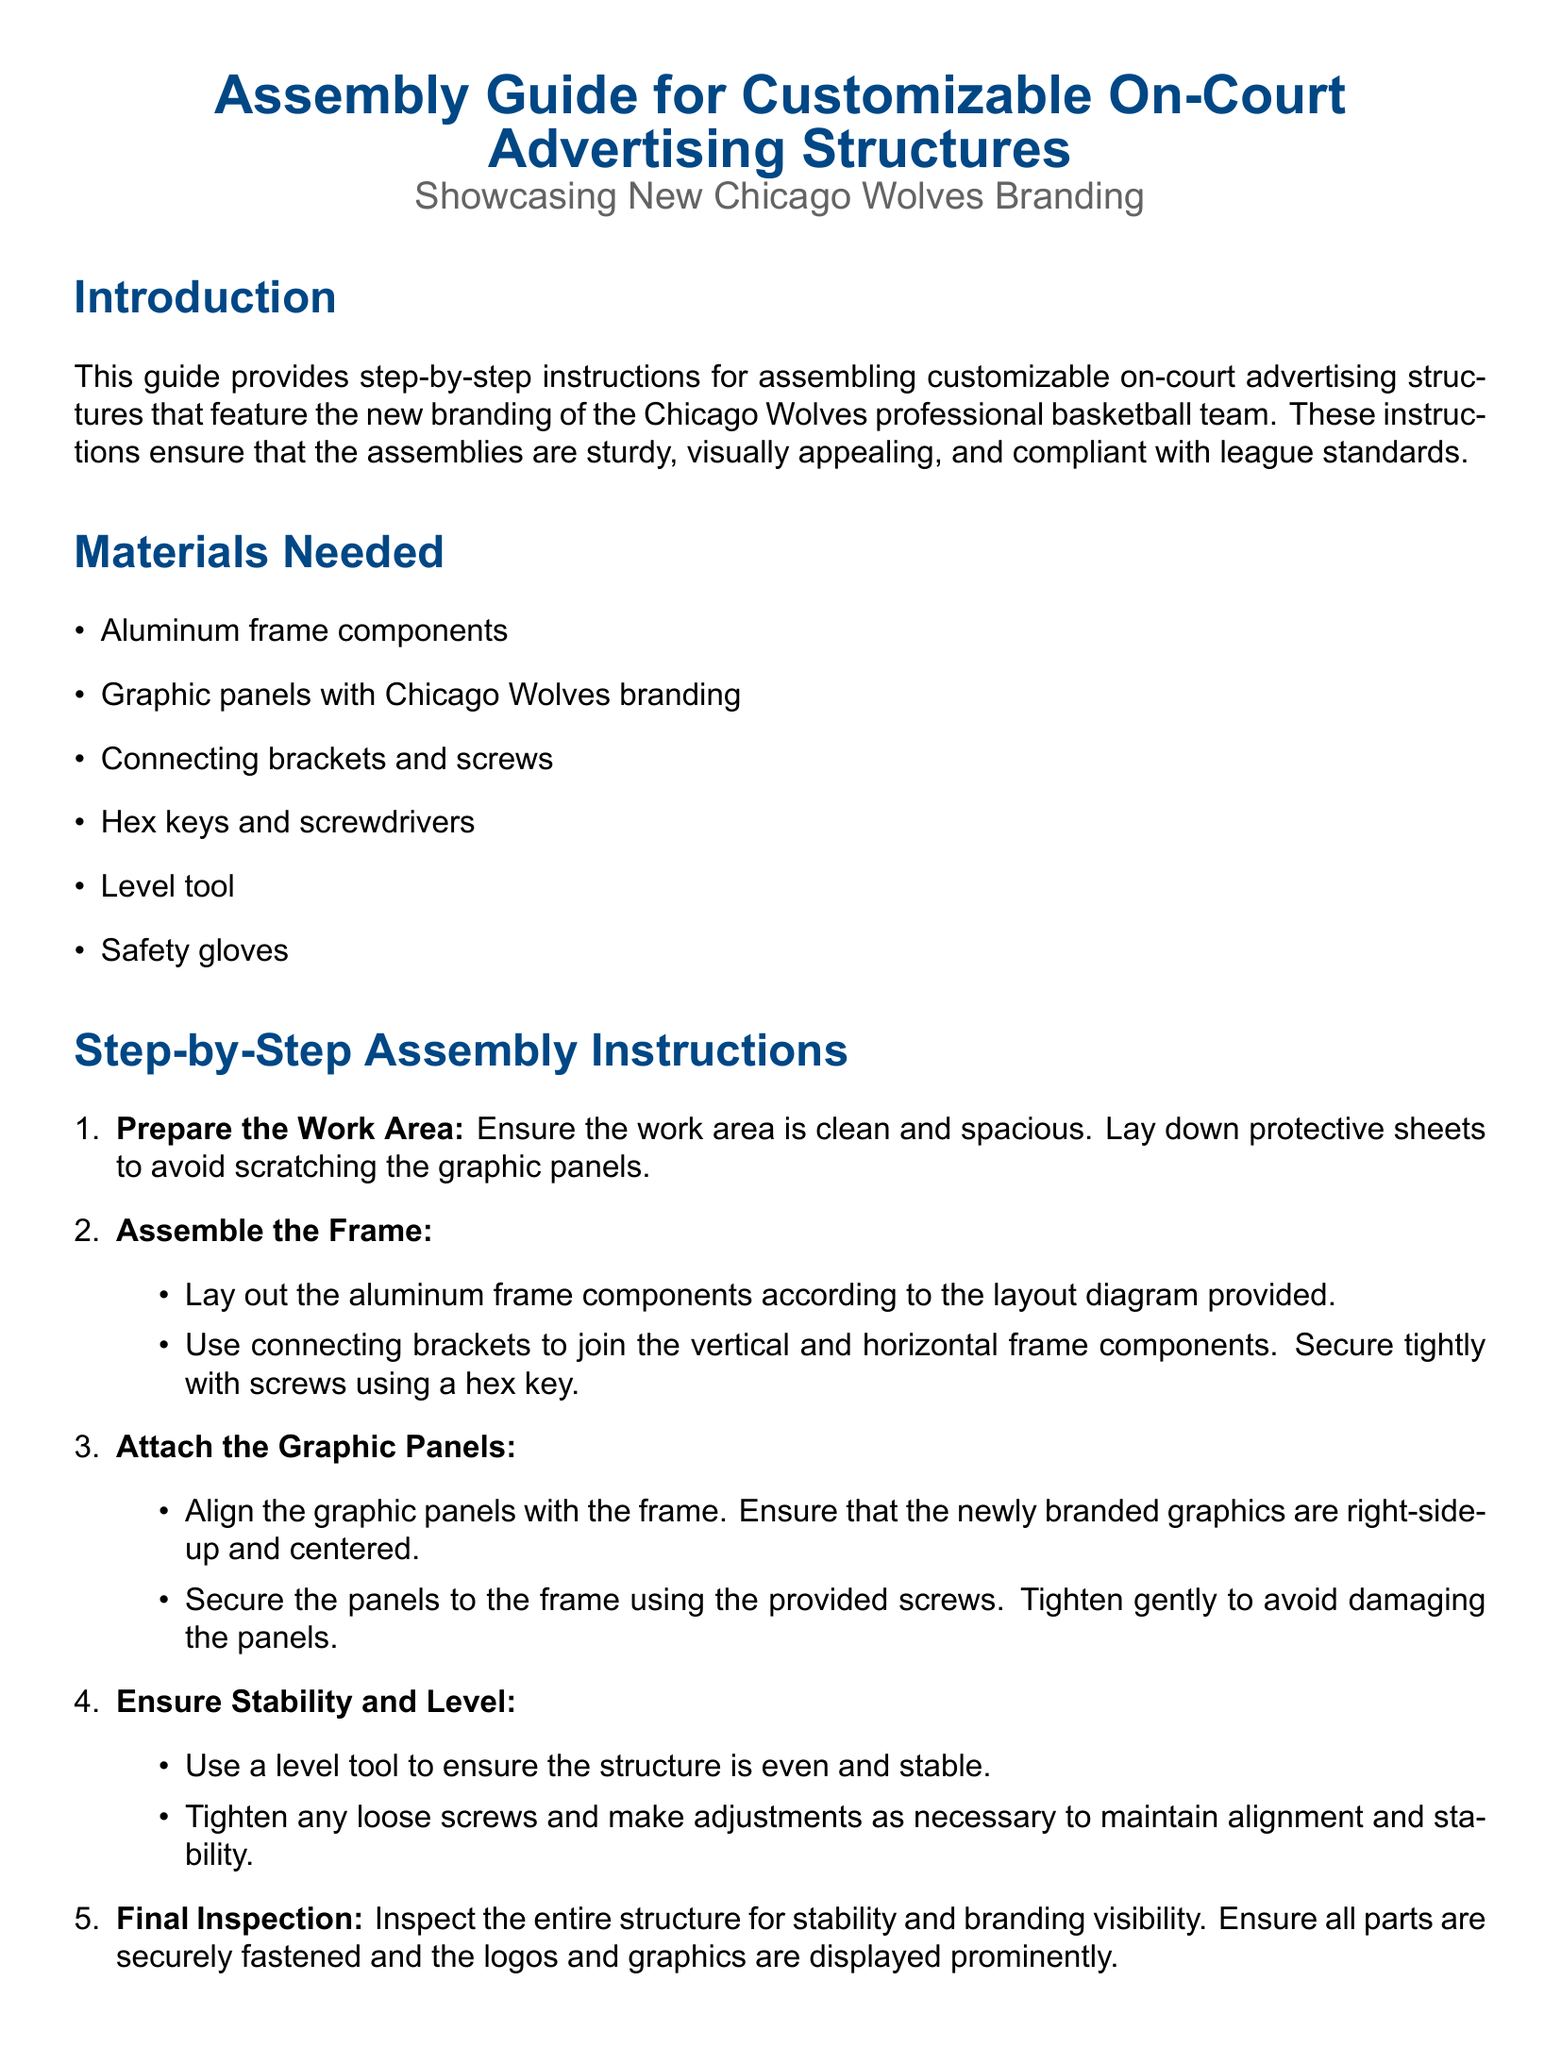What is the title of the document? The title is specified at the top of the document and gives insight into its content regarding assembly instructions.
Answer: Assembly Guide for Customizable On-Court Advertising Structures How many materials are needed for assembly? The materials needed are listed in a bulleted list within the document under "Materials Needed."
Answer: 6 What is the first step in the assembly instructions? The steps for assembly are presented in an enumerated list, with the first item describing the initial preparation needed.
Answer: Prepare the Work Area What color is the header text? The color for header text is defined in the document to help it stand out, specifically noted in the key sections.
Answer: Wolfblue What should you use to secure the graphic panels? The document specifies the tools and fasteners needed for securing components during assembly.
Answer: Provided screws What is the safety tip regarding hand protection? Information about safety measures is included in a list to ensure the safety of individuals assembling the structure.
Answer: Wear safety gloves Which tool is recommended for ensuring the structure is even? The instructions mention a specific tool needed to check the level of the assembled structure.
Answer: Level tool How can you contact the Chicago Wolves branding team? Contact information is provided in a box at the bottom of the document for further assistance.
Answer: branding@chicagowolves.com What is emphasized in the final inspection step? The last assembly step highlights essential checks to ensure everything is as it should be before use.
Answer: Stability and branding visibility 